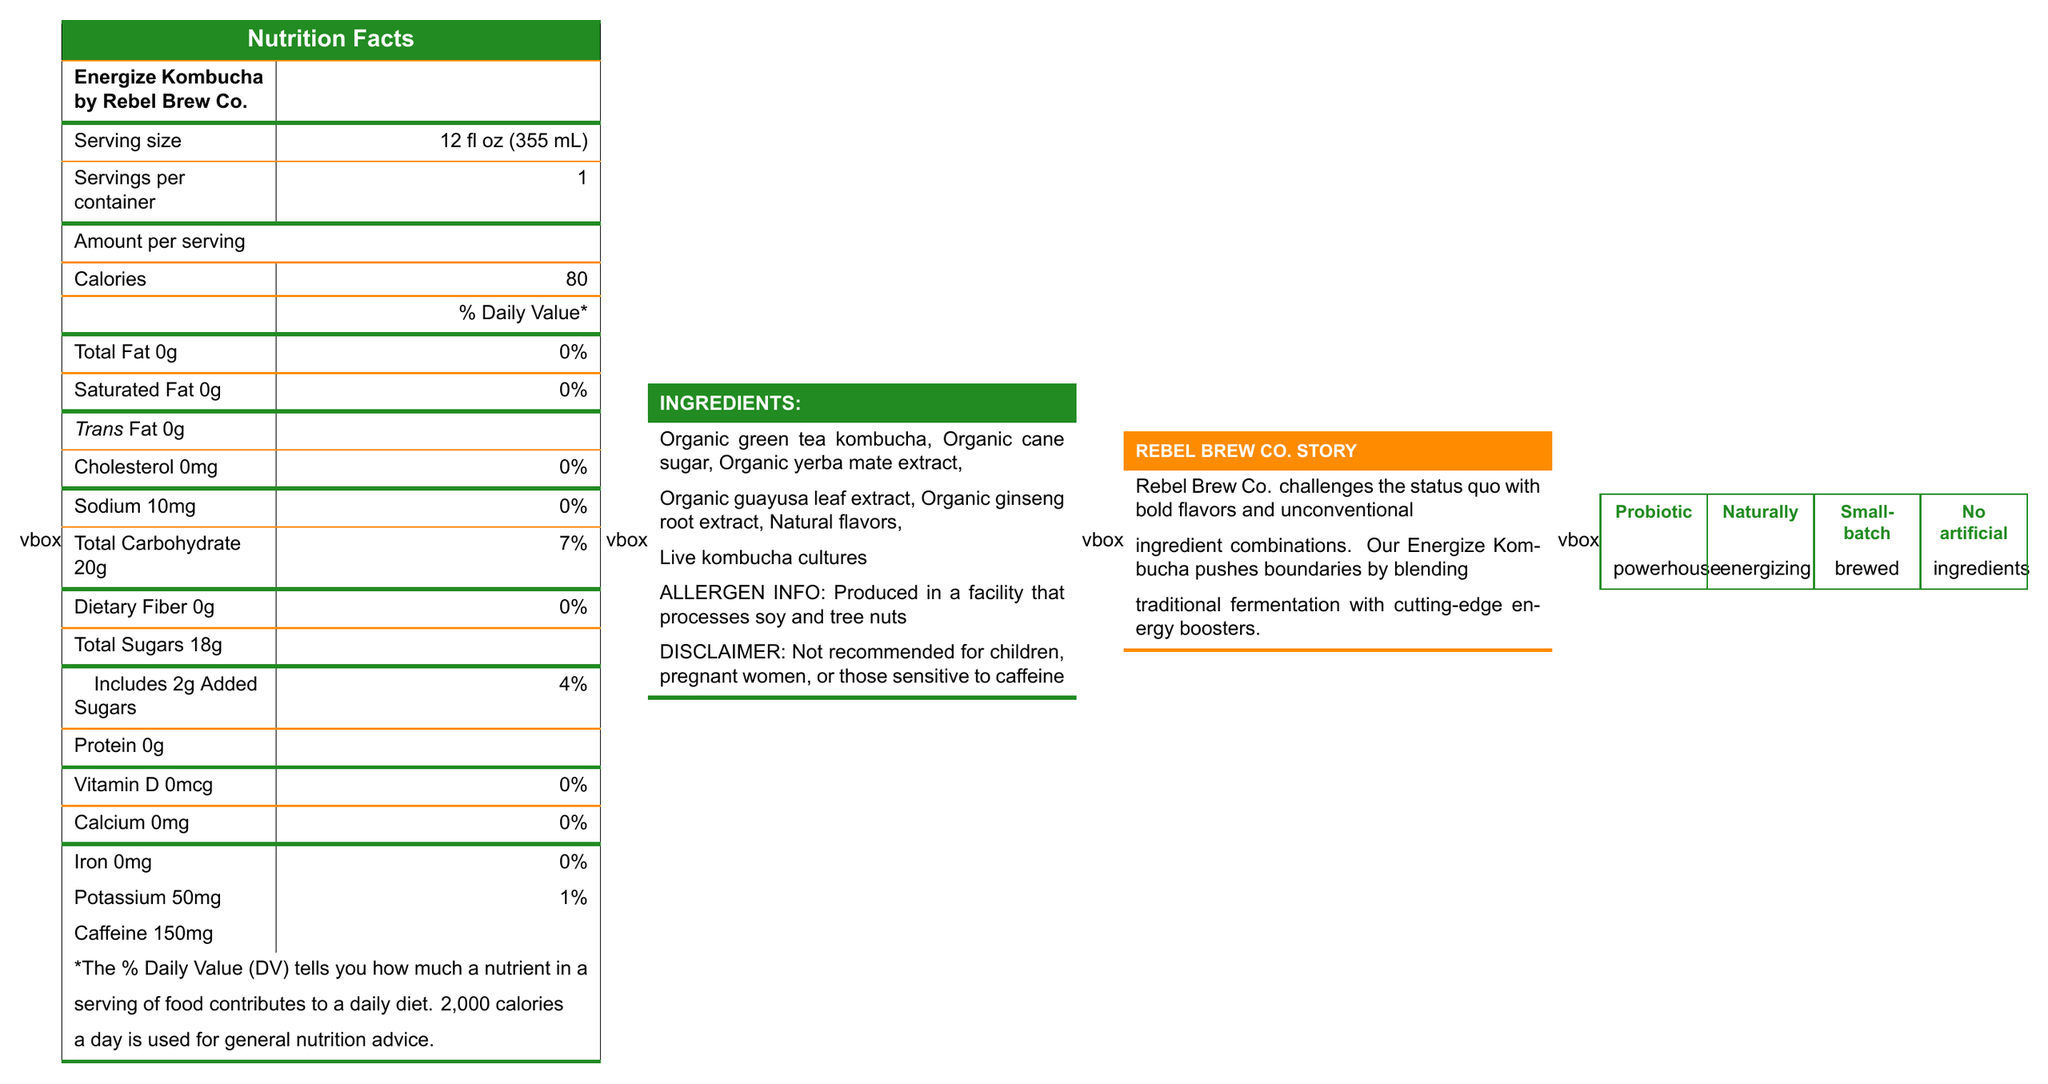what is the serving size of Energize Kombucha by Rebel Brew Co.? The serving size is explicitly stated in the nutrition facts section of the document.
Answer: 12 fl oz (355 mL) how many total sugars are in a serving? The amount of total sugars is listed in the nutrition facts under "Total Sugars."
Answer: 18g what is the percentage of Daily Value for Total Carbohydrate? It is shown next to "Total Carbohydrate" in the nutrition facts, indicating that one serving contributes 7% of the daily value.
Answer: 7% does the product contain any allergens? It is stated in the allergen info that the product is produced in a facility that processes soy and tree nuts.
Answer: Yes what is the caffeine content per serving? The caffeine content per serving is listed at the end of the nutrition facts panel.
Answer: 150mg which ingredient is not organic? All other ingredients are labeled as organic, but "Natural flavors" is not prefixed with "organic."
Answer: Natural flavors how many calories are in a single serving? The calories per serving are clearly mentioned as 80 in the nutrition facts.
Answer: 80 what are the marketing claims made for the product? A. Small-batch brewed B. Low calorie C. Probiotic powerhouse D. No artificial ingredients The marketing claims listed are "Probiotic powerhouse," "Naturally energizing," "Small-batch brewed," and "No artificial ingredients." "Low calorie" is not mentioned.
Answer: B which of these constitutes a disclaimer associated with the product? A. Contains gluten B. Not recommended for children, pregnant women, or those sensitive to caffeine C. Store in a cool, dry place D. Consume within 7 days after opening The disclaimer mentioned in the document is "Not recommended for children, pregnant women, or those sensitive to caffeine."
Answer: B does the product contain any protein? The nutrition facts indicate that the protein content is 0g.
Answer: No what are the executive concerns mentioned in the document? The executive concerns are not visible or referenced within the visual document provided.
Answer: Cannot be determined is this product marketed towards young professionals? The document mentions that the target demographic is 18-35 year old urban professionals.
Answer: Yes summarize the main idea of the document The document, formatted in an eye-catching and colorful style, presents the necessary nutritional details, ingredients, and brand information important for consumers. It also includes strong marketing claims that emphasize the unique aspects of the product.
Answer: The document provides detailed nutritional information for Energize Kombucha by Rebel Brew Co. It highlights its serving size, calories, macronutrients, caffeine content, and ingredients. Allergens and disclaimers are mentioned, alongside bold marketing claims and a short story about the brand's mission to challenge conventional beverage norms. 